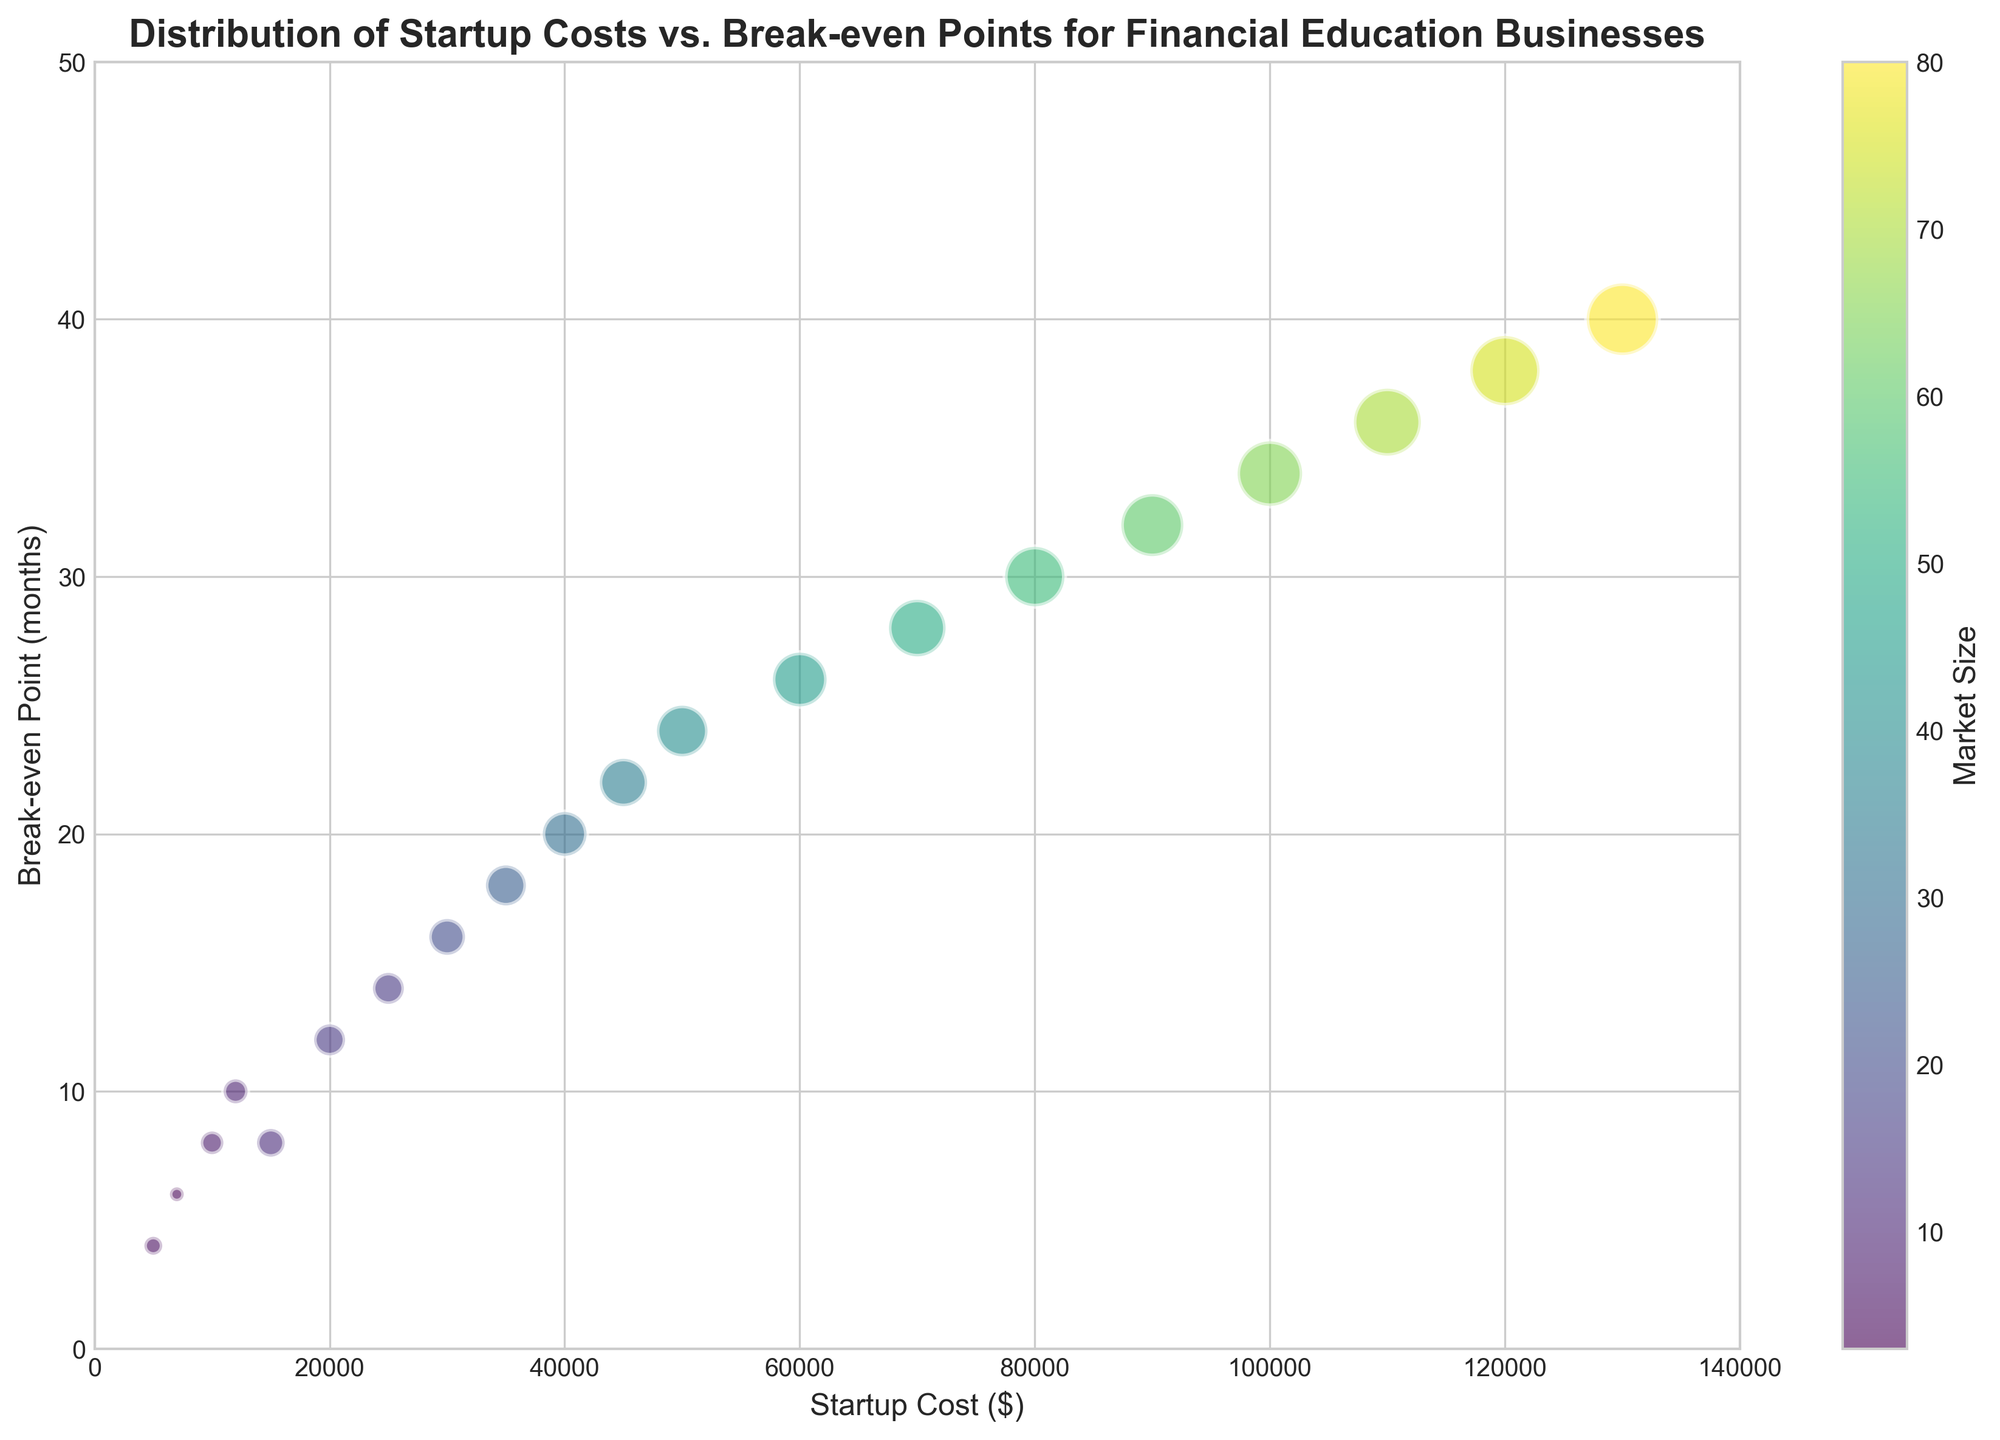What is the relationship between Startup Cost and Break-even Point? The figure demonstrates that as the Startup Cost increases, the Break-even Point in months also increases. This is indicated by the upward trend of the bubbles from left to right.
Answer: As Startup Cost increases, Break-even Point increases Which business has the largest Market Size and what are its Startup Cost and Break-even Point? The biggest bubble in the chart represents the business with the largest Market Size. The largest bubble corresponds to a Market Size of 80, which is for a business with a Startup Cost of 130,000 and a Break-even Point of 40 months.
Answer: Startup Cost: 130,000, Break-even Point: 40 months Compare the Break-even Points for businesses with Startup Costs of 30,000 and 100,000. The bubble for a Startup Cost of 30,000 has a Break-even Point of 16 months, while the bubble for a Startup Cost of 100,000 has a Break-even Point of 34 months. Thus, the Break-even Point for the 100,000 Startup Cost is longer than for the 30,000 Startup Cost.
Answer: Break-even Point for 30,000: 16 months, for 100,000: 34 months Which business with a Break-even Point of 8 months has the larger Market Size, and what is its Startup Cost? There are two businesses with a Break-even Point of 8 months. By looking at the sizes of these two bubbles, the larger one has a Market Size of 12, associated with a Startup Cost of 15,000.
Answer: Startup Cost: 15,000, Market Size: 12 How does the Market Size change with the increasing Break-even Point? The color intensity and size of the bubbles generally increase from left to right. This signifies that as the Break-even Point increases, the Market Size tends to increase as well. This indicates a positive correlation.
Answer: Market Size increases with Break-even Point What is the smallest Startup Cost for a Market Size of 20, and what is the corresponding Break-even Point? The smallest value for the Market Size of 20 can be identified by looking for the smallest bubble that has a Market Size of 20. This is seen with a Startup Cost of 30,000 and a Break-even Point of 16 months.
Answer: Startup Cost: 30,000, Break-even Point: 16 months What is the difference in Break-even Points between the businesses with the smallest and largest Market Sizes? The smallest Market Size is 3 with a Break-even Point of 6 months, and the largest Market Size is 80 with a Break-even Point of 40 months. The difference in Break-even Points is 40 - 6 = 34 months.
Answer: 34 months Is there a business with a lower Startup Cost but a higher Break-even Point than another business? If so, which ones? Comparing the bubbles where some bubbles are positioned higher (higher Break-even Points) yet to the left (lower Startup Costs), we see that a business with a Startup Cost of 15,000 and a Break-even Point of 8 months is lower in Break-even Point and higher in Startup Cost compared to a business with a Startup Cost of 10,000 and Break-even Point of 8 months.
Answer: Yes. Startup Costs: 15,000 vs 10,000, Break-even Points: 8 vs. 8 months How many months does a business with a $70,000 Startup Cost take to break even, and what is its Market Size? Finding the bubble corresponding to a $70,000 Startup Cost, we observe that it has a Break-even Point of 28 months and a Market Size of 50.
Answer: Break-even Point: 28 months, Market Size: 50 By how many months does the Break-even Point increase when the Startup Cost rises from $5,000 to $130,000? The Break-even Point for a $5,000 Startup Cost is 4 months, and for a $130,000 Startup Cost it is 40 months. Therefore, the increase is 40 - 4 = 36 months.
Answer: 36 months 